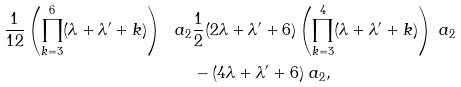<formula> <loc_0><loc_0><loc_500><loc_500>\frac { 1 } { 1 2 } \left ( \prod _ { k = 3 } ^ { 6 } ( \lambda + \lambda ^ { \prime } + k ) \right ) \ a _ { 2 } & \frac { 1 } { 2 } ( 2 \lambda + \lambda ^ { \prime } + 6 ) \left ( \prod _ { k = 3 } ^ { 4 } ( \lambda + \lambda ^ { \prime } + k ) \right ) \ a _ { 2 } \\ & - ( 4 \lambda + \lambda ^ { \prime } + 6 ) \ a _ { 2 } ,</formula> 